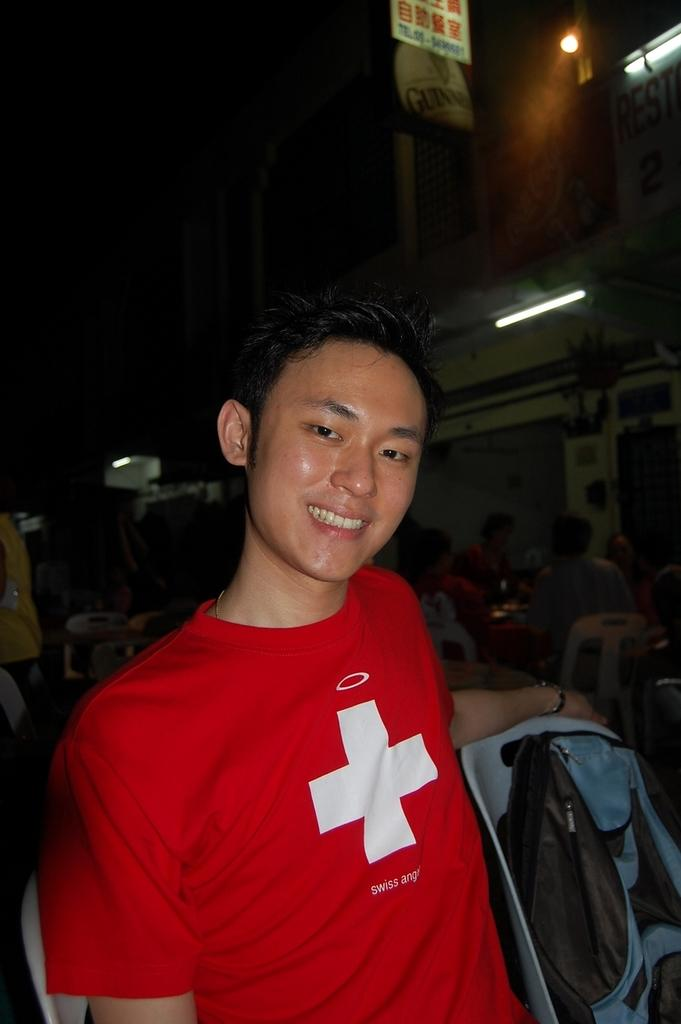What is the man in the image doing? The man is sitting and smiling in the image. What can be seen on the chair beside the man? There is a bag on the chair beside the man. How would you describe the lighting in the image? The background of the image is dark, but there are lights visible in the background. Can you describe the setting in the background of the image? There are people present in the background, and there is a board visible. What type of veil is draped over the man's head in the image? There is no veil present in the image; the man is simply sitting and smiling. 